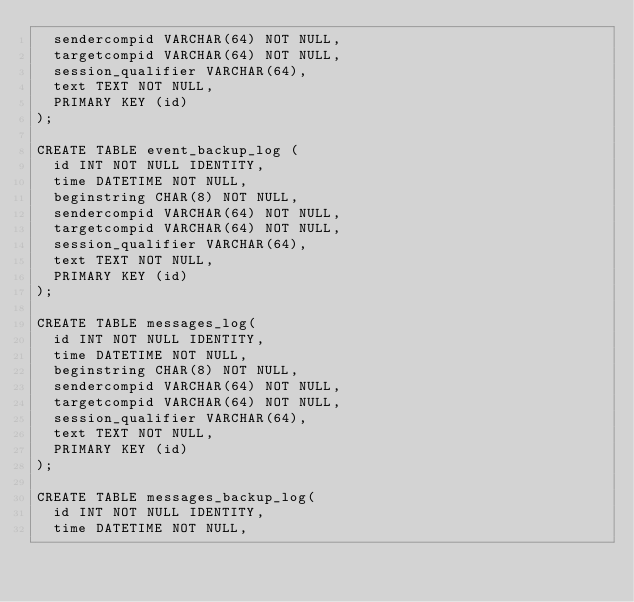<code> <loc_0><loc_0><loc_500><loc_500><_SQL_>  sendercompid VARCHAR(64) NOT NULL,
  targetcompid VARCHAR(64) NOT NULL,
  session_qualifier VARCHAR(64),
  text TEXT NOT NULL,
  PRIMARY KEY (id)
);

CREATE TABLE event_backup_log (
  id INT NOT NULL IDENTITY,
  time DATETIME NOT NULL,
  beginstring CHAR(8) NOT NULL,
  sendercompid VARCHAR(64) NOT NULL,
  targetcompid VARCHAR(64) NOT NULL,
  session_qualifier VARCHAR(64),
  text TEXT NOT NULL,
  PRIMARY KEY (id)
);

CREATE TABLE messages_log(
  id INT NOT NULL IDENTITY,
  time DATETIME NOT NULL,
  beginstring CHAR(8) NOT NULL,
  sendercompid VARCHAR(64) NOT NULL,
  targetcompid VARCHAR(64) NOT NULL,
  session_qualifier VARCHAR(64),
  text TEXT NOT NULL,
  PRIMARY KEY (id)
);

CREATE TABLE messages_backup_log(
  id INT NOT NULL IDENTITY,
  time DATETIME NOT NULL,</code> 